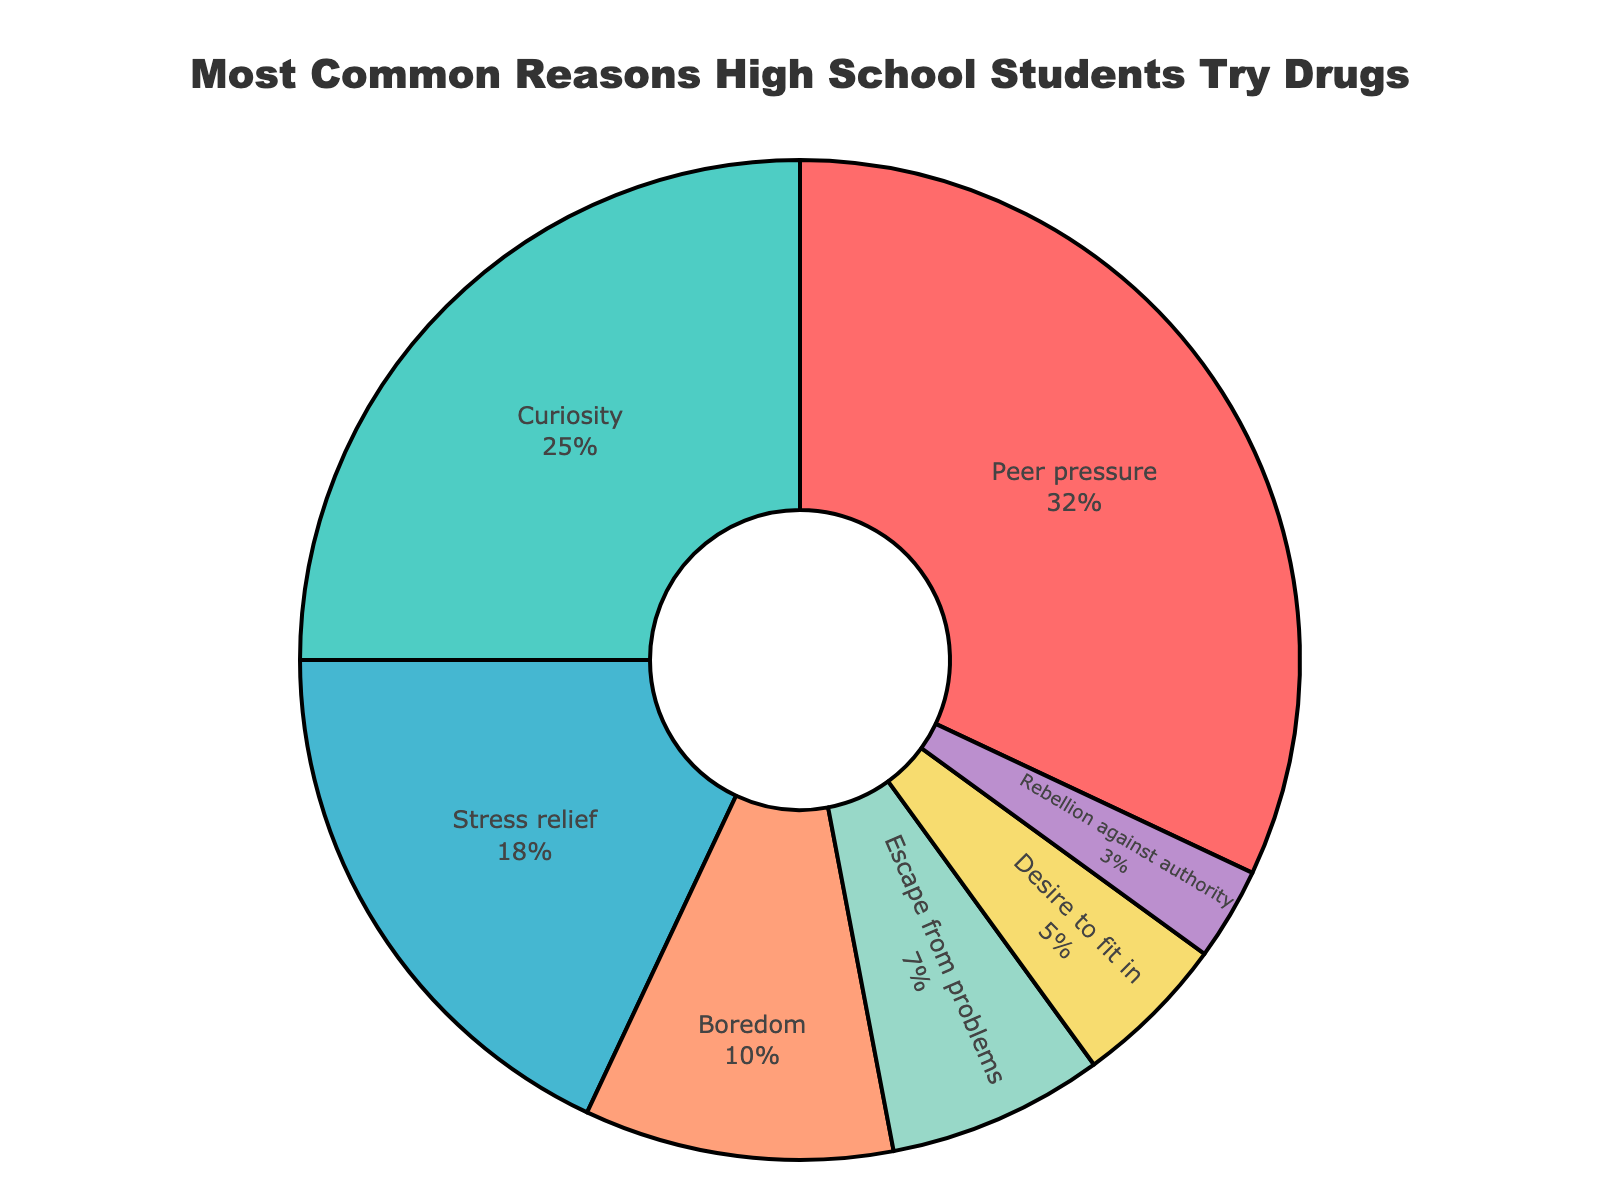What is the most common reason high school students try drugs for the first time? The most common reason can be found by looking at the largest segment of the pie chart. The label with the highest percentage is "Peer pressure" with 32%.
Answer: Peer pressure What is the combined percentage of students who try drugs due to curiosity or stress relief? To find the combined percentage, add the percentages of the two reasons. Curiosity is 25% and stress relief is 18%. 25% + 18% = 43%.
Answer: 43% Which is less common, trying drugs due to boredom or a desire to fit in? Compare the percentages labeled for boredom (10%) and the desire to fit in (5%). Since 10% is greater than 5%, trying drugs due to the desire to fit in is less common.
Answer: Desire to fit in By how much does the percentage of students who try drugs due to peer pressure exceed those who do it out of boredom? Calculate the difference between the percentages for peer pressure (32%) and boredom (10%). 32% - 10% = 22%.
Answer: 22% What is the second most common reason high school students try drugs for the first time? The second most common reason is found by looking at the next largest segment after the largest one. The label with the second highest percentage is "Curiosity" with 25%.
Answer: Curiosity How many categories have a percentage less than 10%? Inspect the pie chart for categories with percentages less than 10%. Boredom (10%), Escape from problems (7%), Desire to fit in (5%), and Rebellion against authority (3%) fit the criteria. Counting these categories, there are 3 categories.
Answer: 3 categories Which reason has a larger percentage, escape from problems or rebellion against authority? Examine the pie chart to compare the percentages of escape from problems (7%) and rebellion against authority (3%). Since 7% is larger than 3%, escape from problems has a larger percentage.
Answer: Escape from problems What is the average percentage of students trying drugs due to boredom, escape from problems, and rebellion against authority? To find the average, sum the percentages of the three categories and divide by 3. Boredom (10%), escape from problems (7%), and rebellion against authority (3%). (10% + 7% + 3%) / 3 = 6.67%.
Answer: 6.67% Which reason is represented by the green segment in the pie chart? Identify the green segment in the pie chart. It corresponds to the value of 25%, which is labeled as "Curiosity".
Answer: Curiosity By how much does the percentage for stress relief exceed that for desire to fit in? Calculate the difference between the percentages for stress relief (18%) and desire to fit in (5%). 18% - 5% = 13%.
Answer: 13% 